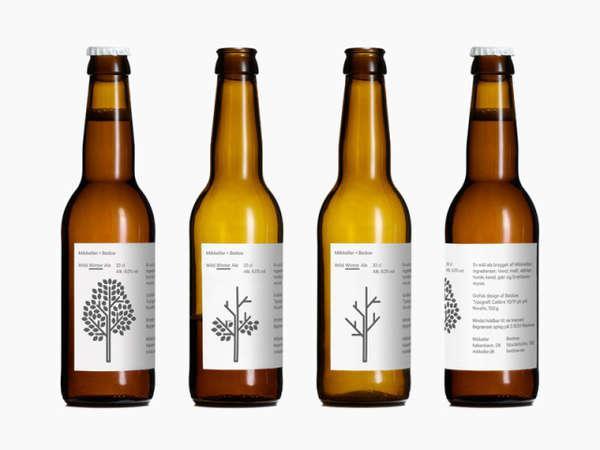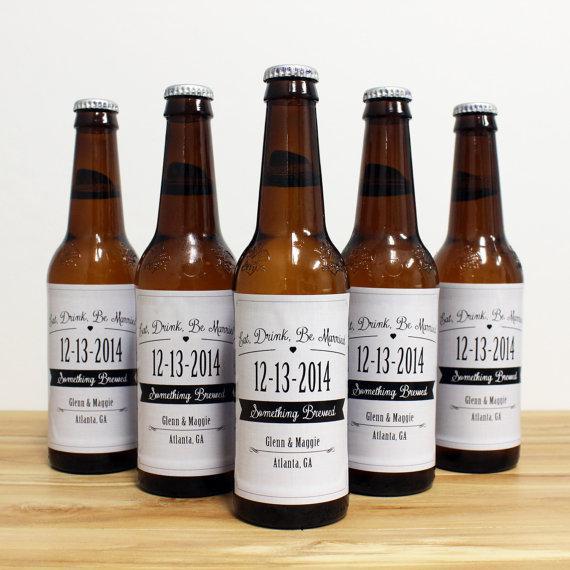The first image is the image on the left, the second image is the image on the right. Assess this claim about the two images: "An image features exactly four bottles in a row.". Correct or not? Answer yes or no. Yes. 